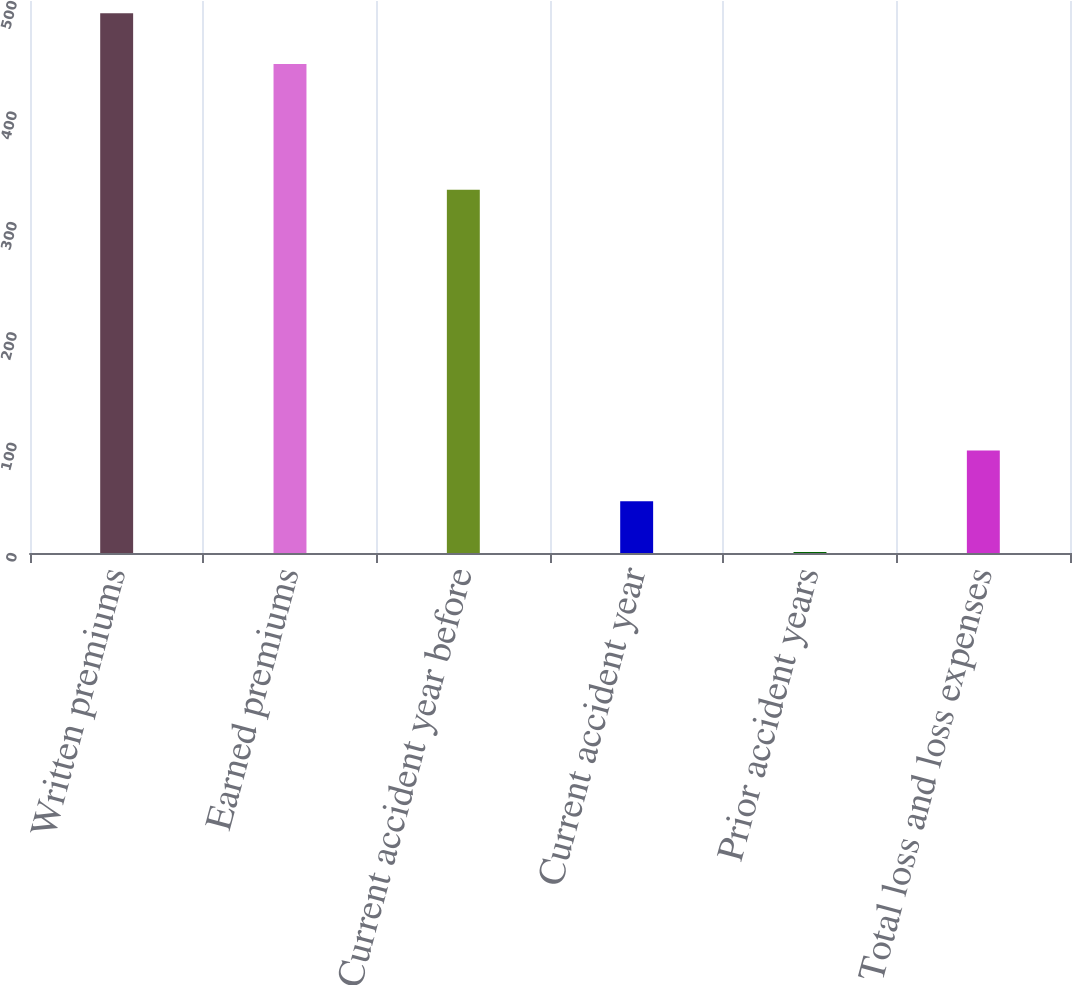<chart> <loc_0><loc_0><loc_500><loc_500><bar_chart><fcel>Written premiums<fcel>Earned premiums<fcel>Current accident year before<fcel>Current accident year<fcel>Prior accident years<fcel>Total loss and loss expenses<nl><fcel>488.9<fcel>443<fcel>329<fcel>46.9<fcel>1<fcel>92.8<nl></chart> 